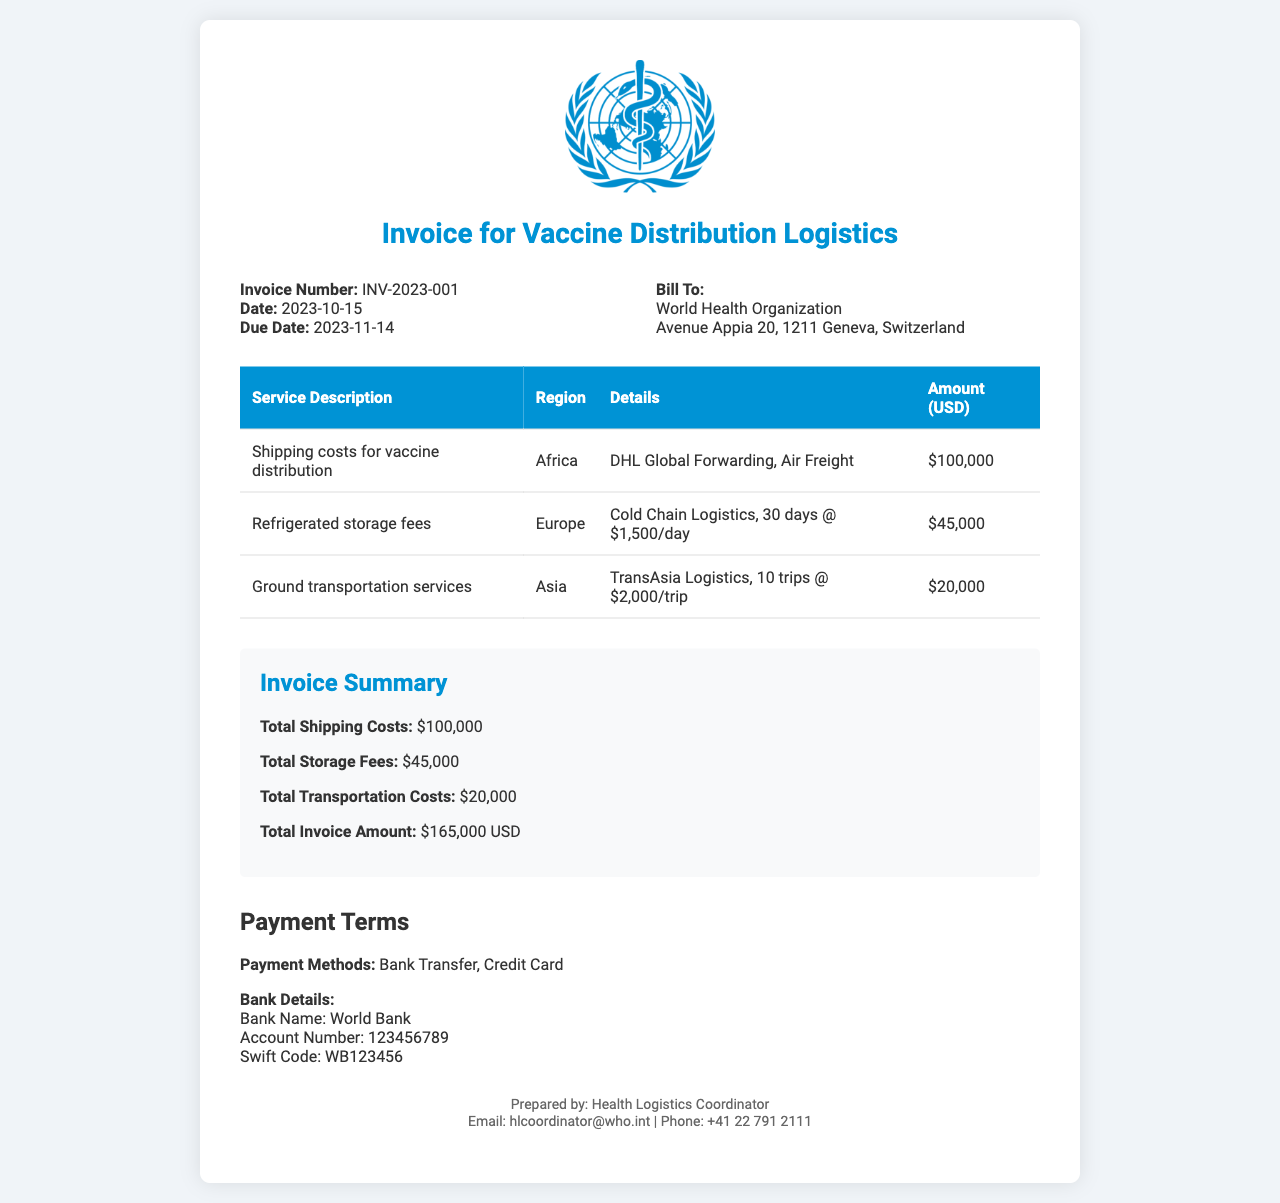What is the invoice number? The invoice number is specified in the document as INV-2023-001.
Answer: INV-2023-001 What is the total invoice amount? The total invoice amount is listed at the bottom of the summary section, which adds up all costs.
Answer: $165,000 USD What are the payment methods stated? The payment methods mentioned in the payment terms section are specifically listed.
Answer: Bank Transfer, Credit Card Which region has the highest shipping costs? The document lists shipping costs per region; comparing them shows Africa has the highest shipping costs.
Answer: Africa What is the due date for the invoice? The due date is clearly stated in the invoice details section.
Answer: 2023-11-14 How many trips were made for ground transportation services? The number of trips for ground transportation is included in the details for that service.
Answer: 10 trips What is the total amount charged for refrigerated storage fees? The total amount for refrigerated storage fees is provided in the summary section.
Answer: $45,000 Who prepared the invoice? The contact info section lists the individual who prepared the invoice.
Answer: Health Logistics Coordinator 